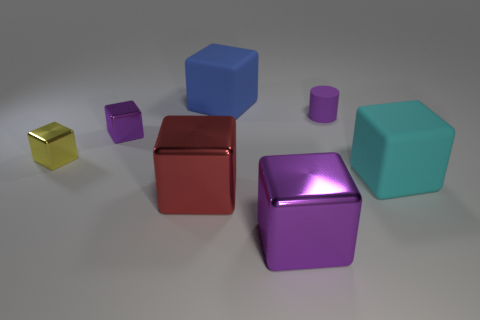Does the tiny metal object on the right side of the yellow shiny object have the same color as the cube in front of the red thing?
Offer a terse response. Yes. Are there any other things that have the same color as the small rubber cylinder?
Offer a very short reply. Yes. Are there fewer large blue rubber cubes that are in front of the big blue matte object than tiny objects?
Provide a short and direct response. Yes. What number of big cyan rubber things are there?
Provide a succinct answer. 1. There is a blue rubber object; does it have the same shape as the tiny purple thing in front of the purple rubber cylinder?
Provide a short and direct response. Yes. Are there fewer small yellow blocks on the left side of the yellow shiny thing than rubber cubes that are behind the small purple cylinder?
Ensure brevity in your answer.  Yes. Is there anything else that has the same shape as the purple rubber thing?
Keep it short and to the point. No. Is the large red object the same shape as the tiny yellow metallic object?
Make the answer very short. Yes. How big is the cyan thing?
Keep it short and to the point. Large. There is a object that is in front of the tiny matte cylinder and right of the large purple object; what is its color?
Ensure brevity in your answer.  Cyan. 